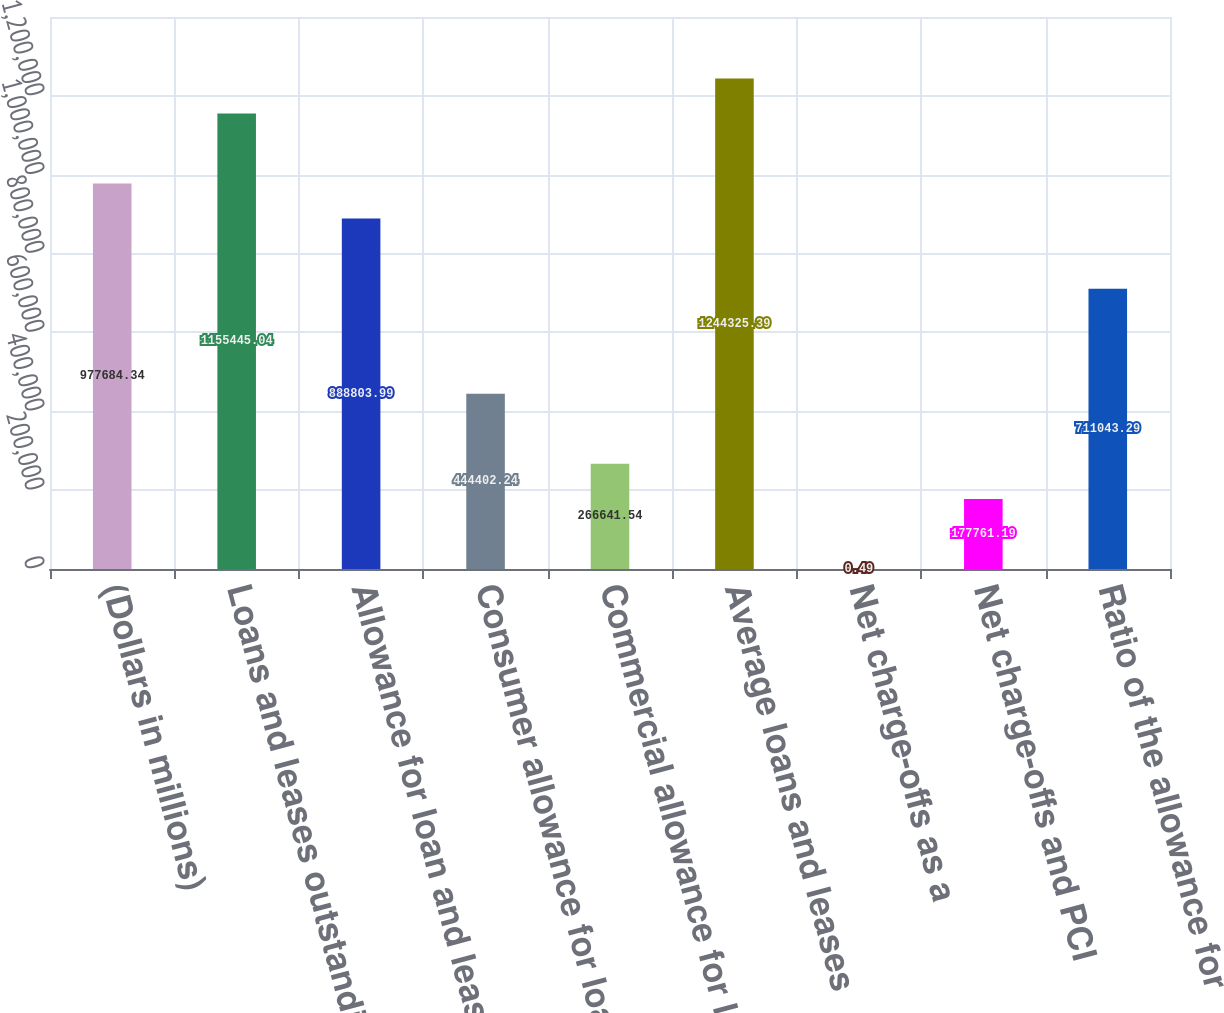Convert chart. <chart><loc_0><loc_0><loc_500><loc_500><bar_chart><fcel>(Dollars in millions)<fcel>Loans and leases outstanding<fcel>Allowance for loan and lease<fcel>Consumer allowance for loan<fcel>Commercial allowance for loan<fcel>Average loans and leases<fcel>Net charge-offs as a<fcel>Net charge-offs and PCI<fcel>Ratio of the allowance for<nl><fcel>977684<fcel>1.15545e+06<fcel>888804<fcel>444402<fcel>266642<fcel>1.24433e+06<fcel>0.49<fcel>177761<fcel>711043<nl></chart> 